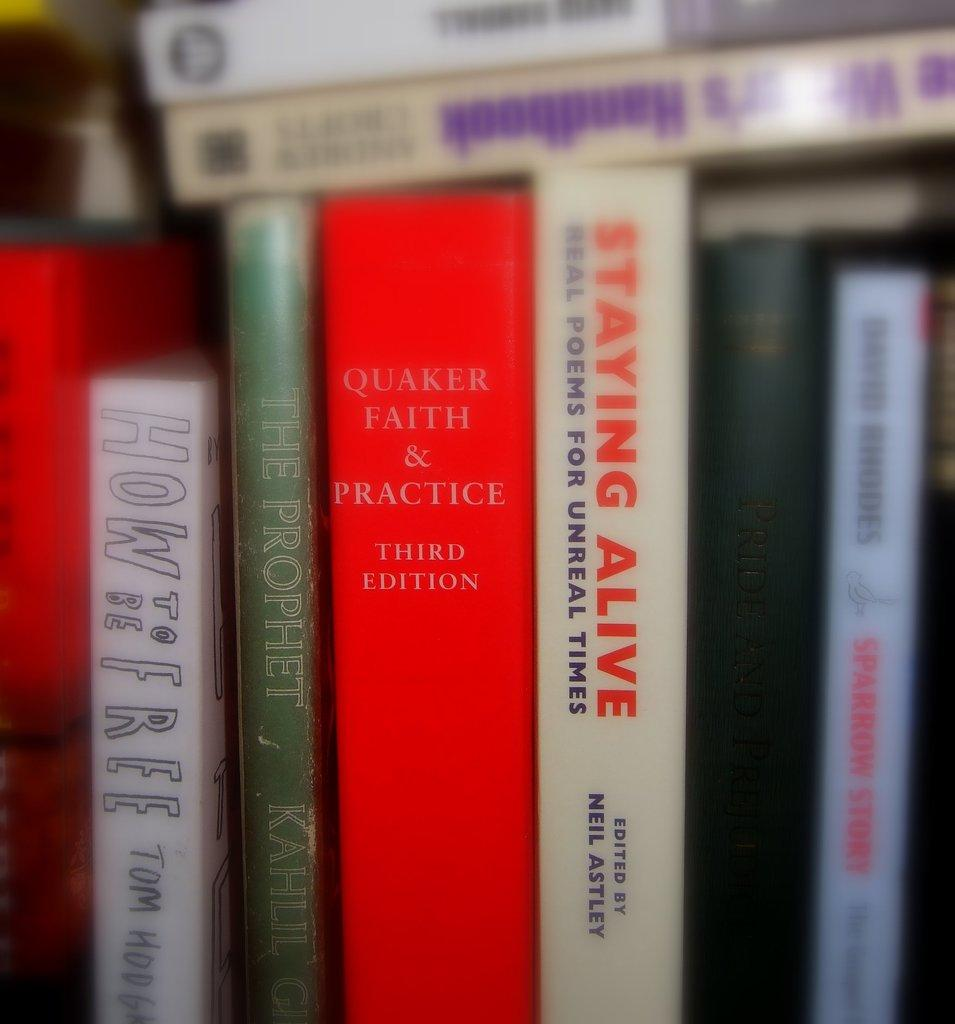Provide a one-sentence caption for the provided image. a stack of books with one saying staying alive in red. 